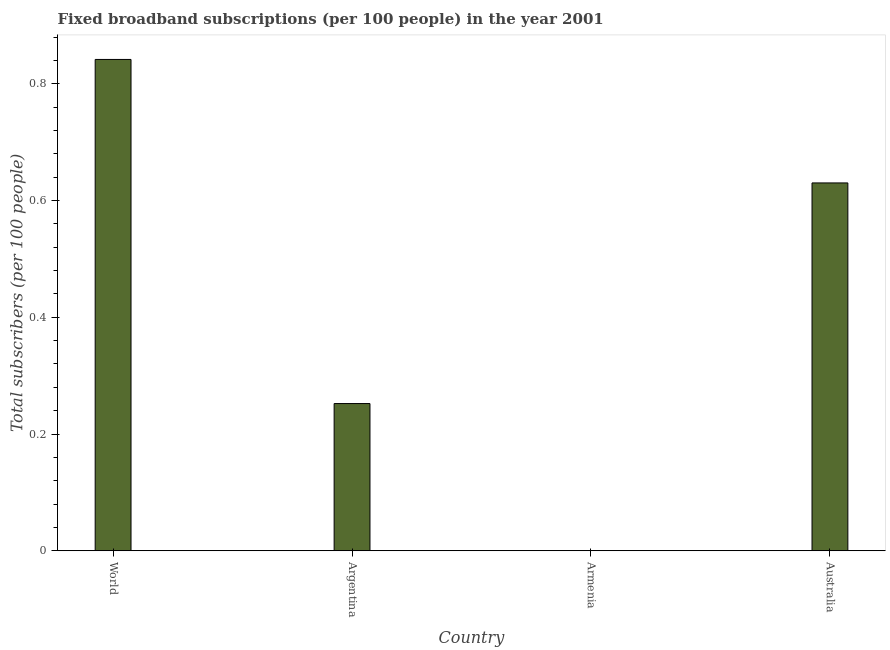Does the graph contain grids?
Provide a short and direct response. No. What is the title of the graph?
Give a very brief answer. Fixed broadband subscriptions (per 100 people) in the year 2001. What is the label or title of the Y-axis?
Give a very brief answer. Total subscribers (per 100 people). What is the total number of fixed broadband subscriptions in Armenia?
Your answer should be very brief. 0. Across all countries, what is the maximum total number of fixed broadband subscriptions?
Your response must be concise. 0.84. Across all countries, what is the minimum total number of fixed broadband subscriptions?
Offer a terse response. 0. In which country was the total number of fixed broadband subscriptions minimum?
Your response must be concise. Armenia. What is the sum of the total number of fixed broadband subscriptions?
Make the answer very short. 1.72. What is the difference between the total number of fixed broadband subscriptions in Argentina and World?
Offer a terse response. -0.59. What is the average total number of fixed broadband subscriptions per country?
Provide a short and direct response. 0.43. What is the median total number of fixed broadband subscriptions?
Make the answer very short. 0.44. In how many countries, is the total number of fixed broadband subscriptions greater than 0.8 ?
Ensure brevity in your answer.  1. What is the ratio of the total number of fixed broadband subscriptions in Australia to that in World?
Give a very brief answer. 0.75. Is the difference between the total number of fixed broadband subscriptions in Armenia and World greater than the difference between any two countries?
Keep it short and to the point. Yes. What is the difference between the highest and the second highest total number of fixed broadband subscriptions?
Offer a terse response. 0.21. Is the sum of the total number of fixed broadband subscriptions in Armenia and World greater than the maximum total number of fixed broadband subscriptions across all countries?
Offer a terse response. Yes. What is the difference between the highest and the lowest total number of fixed broadband subscriptions?
Your answer should be compact. 0.84. In how many countries, is the total number of fixed broadband subscriptions greater than the average total number of fixed broadband subscriptions taken over all countries?
Your answer should be compact. 2. How many bars are there?
Offer a very short reply. 4. Are all the bars in the graph horizontal?
Make the answer very short. No. How many countries are there in the graph?
Ensure brevity in your answer.  4. Are the values on the major ticks of Y-axis written in scientific E-notation?
Offer a terse response. No. What is the Total subscribers (per 100 people) in World?
Offer a very short reply. 0.84. What is the Total subscribers (per 100 people) of Argentina?
Keep it short and to the point. 0.25. What is the Total subscribers (per 100 people) of Armenia?
Your answer should be compact. 0. What is the Total subscribers (per 100 people) in Australia?
Provide a succinct answer. 0.63. What is the difference between the Total subscribers (per 100 people) in World and Argentina?
Your answer should be compact. 0.59. What is the difference between the Total subscribers (per 100 people) in World and Armenia?
Provide a succinct answer. 0.84. What is the difference between the Total subscribers (per 100 people) in World and Australia?
Your answer should be very brief. 0.21. What is the difference between the Total subscribers (per 100 people) in Argentina and Armenia?
Keep it short and to the point. 0.25. What is the difference between the Total subscribers (per 100 people) in Argentina and Australia?
Keep it short and to the point. -0.38. What is the difference between the Total subscribers (per 100 people) in Armenia and Australia?
Your answer should be very brief. -0.63. What is the ratio of the Total subscribers (per 100 people) in World to that in Argentina?
Make the answer very short. 3.34. What is the ratio of the Total subscribers (per 100 people) in World to that in Armenia?
Offer a very short reply. 4292.64. What is the ratio of the Total subscribers (per 100 people) in World to that in Australia?
Offer a terse response. 1.34. What is the ratio of the Total subscribers (per 100 people) in Argentina to that in Armenia?
Provide a succinct answer. 1286.16. What is the ratio of the Total subscribers (per 100 people) in Argentina to that in Australia?
Make the answer very short. 0.4. What is the ratio of the Total subscribers (per 100 people) in Armenia to that in Australia?
Offer a very short reply. 0. 